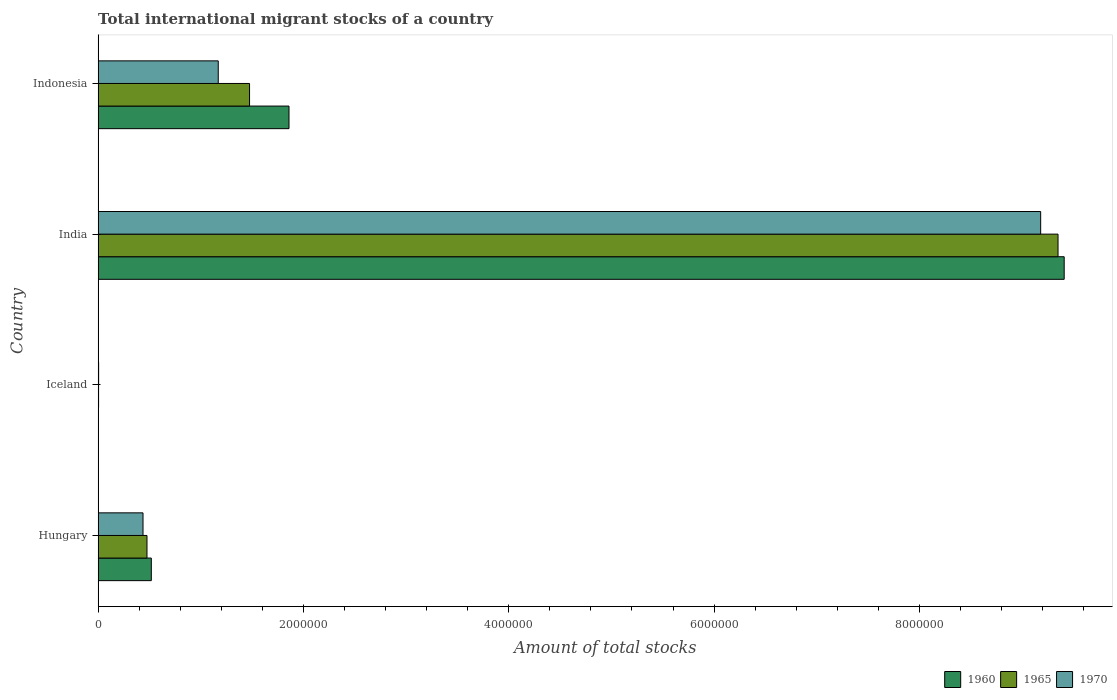What is the label of the 4th group of bars from the top?
Give a very brief answer. Hungary. In how many cases, is the number of bars for a given country not equal to the number of legend labels?
Offer a terse response. 0. What is the amount of total stocks in in 1960 in Indonesia?
Make the answer very short. 1.86e+06. Across all countries, what is the maximum amount of total stocks in in 1960?
Ensure brevity in your answer.  9.41e+06. Across all countries, what is the minimum amount of total stocks in in 1965?
Offer a terse response. 4515. In which country was the amount of total stocks in in 1965 maximum?
Provide a short and direct response. India. In which country was the amount of total stocks in in 1960 minimum?
Offer a terse response. Iceland. What is the total amount of total stocks in in 1965 in the graph?
Make the answer very short. 1.13e+07. What is the difference between the amount of total stocks in in 1960 in Iceland and that in Indonesia?
Provide a succinct answer. -1.86e+06. What is the difference between the amount of total stocks in in 1960 in India and the amount of total stocks in in 1965 in Indonesia?
Ensure brevity in your answer.  7.94e+06. What is the average amount of total stocks in in 1965 per country?
Your answer should be compact. 2.83e+06. What is the difference between the amount of total stocks in in 1965 and amount of total stocks in in 1970 in Indonesia?
Keep it short and to the point. 3.05e+05. In how many countries, is the amount of total stocks in in 1965 greater than 4400000 ?
Your answer should be compact. 1. What is the ratio of the amount of total stocks in in 1960 in Iceland to that in India?
Provide a short and direct response. 0. What is the difference between the highest and the second highest amount of total stocks in in 1965?
Ensure brevity in your answer.  7.88e+06. What is the difference between the highest and the lowest amount of total stocks in in 1965?
Your response must be concise. 9.35e+06. In how many countries, is the amount of total stocks in in 1970 greater than the average amount of total stocks in in 1970 taken over all countries?
Your response must be concise. 1. What does the 2nd bar from the bottom in Indonesia represents?
Provide a succinct answer. 1965. How many bars are there?
Provide a short and direct response. 12. What is the difference between two consecutive major ticks on the X-axis?
Give a very brief answer. 2.00e+06. Does the graph contain grids?
Provide a short and direct response. No. How many legend labels are there?
Keep it short and to the point. 3. How are the legend labels stacked?
Provide a succinct answer. Horizontal. What is the title of the graph?
Offer a very short reply. Total international migrant stocks of a country. Does "1983" appear as one of the legend labels in the graph?
Make the answer very short. No. What is the label or title of the X-axis?
Your response must be concise. Amount of total stocks. What is the Amount of total stocks of 1960 in Hungary?
Give a very brief answer. 5.18e+05. What is the Amount of total stocks of 1965 in Hungary?
Provide a succinct answer. 4.76e+05. What is the Amount of total stocks of 1970 in Hungary?
Provide a short and direct response. 4.37e+05. What is the Amount of total stocks in 1960 in Iceland?
Give a very brief answer. 3317. What is the Amount of total stocks of 1965 in Iceland?
Your answer should be very brief. 4515. What is the Amount of total stocks of 1970 in Iceland?
Your answer should be compact. 4914. What is the Amount of total stocks in 1960 in India?
Your answer should be very brief. 9.41e+06. What is the Amount of total stocks of 1965 in India?
Your answer should be compact. 9.35e+06. What is the Amount of total stocks of 1970 in India?
Ensure brevity in your answer.  9.18e+06. What is the Amount of total stocks in 1960 in Indonesia?
Make the answer very short. 1.86e+06. What is the Amount of total stocks of 1965 in Indonesia?
Provide a short and direct response. 1.48e+06. What is the Amount of total stocks in 1970 in Indonesia?
Ensure brevity in your answer.  1.17e+06. Across all countries, what is the maximum Amount of total stocks in 1960?
Offer a terse response. 9.41e+06. Across all countries, what is the maximum Amount of total stocks in 1965?
Make the answer very short. 9.35e+06. Across all countries, what is the maximum Amount of total stocks in 1970?
Your answer should be compact. 9.18e+06. Across all countries, what is the minimum Amount of total stocks in 1960?
Offer a very short reply. 3317. Across all countries, what is the minimum Amount of total stocks of 1965?
Provide a short and direct response. 4515. Across all countries, what is the minimum Amount of total stocks in 1970?
Offer a terse response. 4914. What is the total Amount of total stocks of 1960 in the graph?
Offer a very short reply. 1.18e+07. What is the total Amount of total stocks in 1965 in the graph?
Provide a succinct answer. 1.13e+07. What is the total Amount of total stocks in 1970 in the graph?
Offer a terse response. 1.08e+07. What is the difference between the Amount of total stocks of 1960 in Hungary and that in Iceland?
Offer a very short reply. 5.15e+05. What is the difference between the Amount of total stocks of 1965 in Hungary and that in Iceland?
Your response must be concise. 4.71e+05. What is the difference between the Amount of total stocks of 1970 in Hungary and that in Iceland?
Ensure brevity in your answer.  4.32e+05. What is the difference between the Amount of total stocks in 1960 in Hungary and that in India?
Your response must be concise. -8.89e+06. What is the difference between the Amount of total stocks of 1965 in Hungary and that in India?
Offer a very short reply. -8.87e+06. What is the difference between the Amount of total stocks in 1970 in Hungary and that in India?
Keep it short and to the point. -8.74e+06. What is the difference between the Amount of total stocks in 1960 in Hungary and that in Indonesia?
Keep it short and to the point. -1.34e+06. What is the difference between the Amount of total stocks in 1965 in Hungary and that in Indonesia?
Provide a short and direct response. -9.99e+05. What is the difference between the Amount of total stocks of 1970 in Hungary and that in Indonesia?
Provide a short and direct response. -7.33e+05. What is the difference between the Amount of total stocks of 1960 in Iceland and that in India?
Give a very brief answer. -9.41e+06. What is the difference between the Amount of total stocks in 1965 in Iceland and that in India?
Provide a succinct answer. -9.35e+06. What is the difference between the Amount of total stocks of 1970 in Iceland and that in India?
Offer a terse response. -9.18e+06. What is the difference between the Amount of total stocks of 1960 in Iceland and that in Indonesia?
Provide a succinct answer. -1.86e+06. What is the difference between the Amount of total stocks of 1965 in Iceland and that in Indonesia?
Your response must be concise. -1.47e+06. What is the difference between the Amount of total stocks in 1970 in Iceland and that in Indonesia?
Your answer should be very brief. -1.17e+06. What is the difference between the Amount of total stocks of 1960 in India and that in Indonesia?
Keep it short and to the point. 7.55e+06. What is the difference between the Amount of total stocks in 1965 in India and that in Indonesia?
Offer a very short reply. 7.88e+06. What is the difference between the Amount of total stocks of 1970 in India and that in Indonesia?
Provide a short and direct response. 8.01e+06. What is the difference between the Amount of total stocks of 1960 in Hungary and the Amount of total stocks of 1965 in Iceland?
Offer a very short reply. 5.14e+05. What is the difference between the Amount of total stocks in 1960 in Hungary and the Amount of total stocks in 1970 in Iceland?
Provide a short and direct response. 5.13e+05. What is the difference between the Amount of total stocks of 1965 in Hungary and the Amount of total stocks of 1970 in Iceland?
Give a very brief answer. 4.71e+05. What is the difference between the Amount of total stocks of 1960 in Hungary and the Amount of total stocks of 1965 in India?
Provide a short and direct response. -8.83e+06. What is the difference between the Amount of total stocks of 1960 in Hungary and the Amount of total stocks of 1970 in India?
Your answer should be very brief. -8.66e+06. What is the difference between the Amount of total stocks in 1965 in Hungary and the Amount of total stocks in 1970 in India?
Offer a very short reply. -8.71e+06. What is the difference between the Amount of total stocks in 1960 in Hungary and the Amount of total stocks in 1965 in Indonesia?
Your response must be concise. -9.57e+05. What is the difference between the Amount of total stocks of 1960 in Hungary and the Amount of total stocks of 1970 in Indonesia?
Offer a very short reply. -6.52e+05. What is the difference between the Amount of total stocks in 1965 in Hungary and the Amount of total stocks in 1970 in Indonesia?
Ensure brevity in your answer.  -6.94e+05. What is the difference between the Amount of total stocks in 1960 in Iceland and the Amount of total stocks in 1965 in India?
Keep it short and to the point. -9.35e+06. What is the difference between the Amount of total stocks of 1960 in Iceland and the Amount of total stocks of 1970 in India?
Offer a very short reply. -9.18e+06. What is the difference between the Amount of total stocks in 1965 in Iceland and the Amount of total stocks in 1970 in India?
Ensure brevity in your answer.  -9.18e+06. What is the difference between the Amount of total stocks in 1960 in Iceland and the Amount of total stocks in 1965 in Indonesia?
Your answer should be compact. -1.47e+06. What is the difference between the Amount of total stocks in 1960 in Iceland and the Amount of total stocks in 1970 in Indonesia?
Offer a very short reply. -1.17e+06. What is the difference between the Amount of total stocks in 1965 in Iceland and the Amount of total stocks in 1970 in Indonesia?
Ensure brevity in your answer.  -1.17e+06. What is the difference between the Amount of total stocks in 1960 in India and the Amount of total stocks in 1965 in Indonesia?
Ensure brevity in your answer.  7.94e+06. What is the difference between the Amount of total stocks of 1960 in India and the Amount of total stocks of 1970 in Indonesia?
Your response must be concise. 8.24e+06. What is the difference between the Amount of total stocks in 1965 in India and the Amount of total stocks in 1970 in Indonesia?
Ensure brevity in your answer.  8.18e+06. What is the average Amount of total stocks of 1960 per country?
Provide a succinct answer. 2.95e+06. What is the average Amount of total stocks of 1965 per country?
Keep it short and to the point. 2.83e+06. What is the average Amount of total stocks of 1970 per country?
Give a very brief answer. 2.70e+06. What is the difference between the Amount of total stocks in 1960 and Amount of total stocks in 1965 in Hungary?
Your answer should be compact. 4.21e+04. What is the difference between the Amount of total stocks in 1960 and Amount of total stocks in 1970 in Hungary?
Make the answer very short. 8.09e+04. What is the difference between the Amount of total stocks in 1965 and Amount of total stocks in 1970 in Hungary?
Your response must be concise. 3.87e+04. What is the difference between the Amount of total stocks in 1960 and Amount of total stocks in 1965 in Iceland?
Your answer should be very brief. -1198. What is the difference between the Amount of total stocks in 1960 and Amount of total stocks in 1970 in Iceland?
Keep it short and to the point. -1597. What is the difference between the Amount of total stocks in 1965 and Amount of total stocks in 1970 in Iceland?
Provide a succinct answer. -399. What is the difference between the Amount of total stocks of 1960 and Amount of total stocks of 1965 in India?
Offer a very short reply. 6.00e+04. What is the difference between the Amount of total stocks in 1960 and Amount of total stocks in 1970 in India?
Offer a terse response. 2.29e+05. What is the difference between the Amount of total stocks of 1965 and Amount of total stocks of 1970 in India?
Keep it short and to the point. 1.69e+05. What is the difference between the Amount of total stocks of 1960 and Amount of total stocks of 1965 in Indonesia?
Your answer should be compact. 3.84e+05. What is the difference between the Amount of total stocks in 1960 and Amount of total stocks in 1970 in Indonesia?
Your response must be concise. 6.89e+05. What is the difference between the Amount of total stocks of 1965 and Amount of total stocks of 1970 in Indonesia?
Provide a succinct answer. 3.05e+05. What is the ratio of the Amount of total stocks in 1960 in Hungary to that in Iceland?
Give a very brief answer. 156.21. What is the ratio of the Amount of total stocks of 1965 in Hungary to that in Iceland?
Give a very brief answer. 105.42. What is the ratio of the Amount of total stocks in 1970 in Hungary to that in Iceland?
Your response must be concise. 88.99. What is the ratio of the Amount of total stocks of 1960 in Hungary to that in India?
Make the answer very short. 0.06. What is the ratio of the Amount of total stocks of 1965 in Hungary to that in India?
Your answer should be very brief. 0.05. What is the ratio of the Amount of total stocks in 1970 in Hungary to that in India?
Provide a succinct answer. 0.05. What is the ratio of the Amount of total stocks in 1960 in Hungary to that in Indonesia?
Your answer should be very brief. 0.28. What is the ratio of the Amount of total stocks of 1965 in Hungary to that in Indonesia?
Offer a very short reply. 0.32. What is the ratio of the Amount of total stocks of 1970 in Hungary to that in Indonesia?
Your response must be concise. 0.37. What is the ratio of the Amount of total stocks in 1960 in Iceland to that in India?
Provide a short and direct response. 0. What is the ratio of the Amount of total stocks of 1970 in Iceland to that in India?
Provide a short and direct response. 0. What is the ratio of the Amount of total stocks in 1960 in Iceland to that in Indonesia?
Your answer should be compact. 0. What is the ratio of the Amount of total stocks in 1965 in Iceland to that in Indonesia?
Your answer should be compact. 0. What is the ratio of the Amount of total stocks in 1970 in Iceland to that in Indonesia?
Your response must be concise. 0. What is the ratio of the Amount of total stocks of 1960 in India to that in Indonesia?
Offer a terse response. 5.06. What is the ratio of the Amount of total stocks of 1965 in India to that in Indonesia?
Ensure brevity in your answer.  6.34. What is the ratio of the Amount of total stocks of 1970 in India to that in Indonesia?
Your response must be concise. 7.85. What is the difference between the highest and the second highest Amount of total stocks of 1960?
Your answer should be very brief. 7.55e+06. What is the difference between the highest and the second highest Amount of total stocks of 1965?
Offer a terse response. 7.88e+06. What is the difference between the highest and the second highest Amount of total stocks of 1970?
Your answer should be very brief. 8.01e+06. What is the difference between the highest and the lowest Amount of total stocks in 1960?
Your answer should be compact. 9.41e+06. What is the difference between the highest and the lowest Amount of total stocks in 1965?
Your response must be concise. 9.35e+06. What is the difference between the highest and the lowest Amount of total stocks in 1970?
Your answer should be very brief. 9.18e+06. 